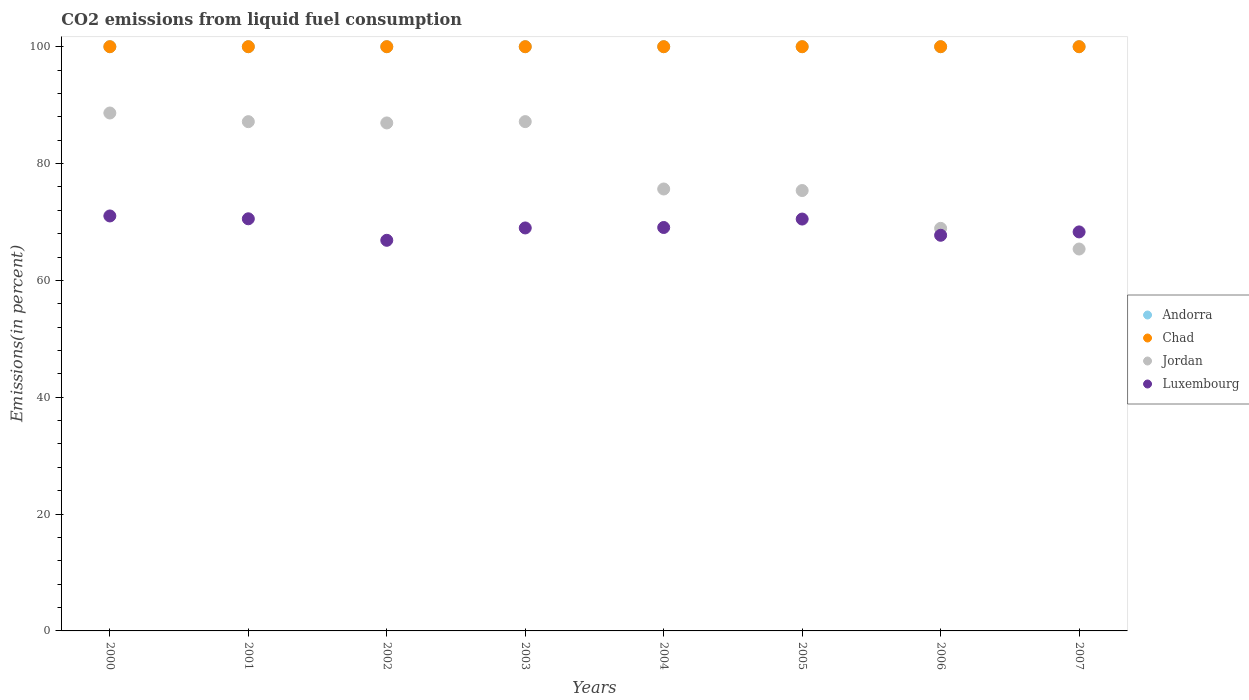Is the number of dotlines equal to the number of legend labels?
Your response must be concise. Yes. What is the total CO2 emitted in Chad in 2000?
Offer a terse response. 100. Across all years, what is the maximum total CO2 emitted in Chad?
Ensure brevity in your answer.  100. Across all years, what is the minimum total CO2 emitted in Luxembourg?
Your answer should be very brief. 66.86. What is the total total CO2 emitted in Luxembourg in the graph?
Provide a short and direct response. 552.98. What is the difference between the total CO2 emitted in Chad in 2002 and that in 2005?
Offer a very short reply. 0. What is the difference between the total CO2 emitted in Andorra in 2003 and the total CO2 emitted in Chad in 2005?
Your answer should be compact. 0. What is the average total CO2 emitted in Luxembourg per year?
Your answer should be very brief. 69.12. In the year 2004, what is the difference between the total CO2 emitted in Andorra and total CO2 emitted in Jordan?
Make the answer very short. 24.36. What is the ratio of the total CO2 emitted in Jordan in 2003 to that in 2005?
Provide a succinct answer. 1.16. Is the difference between the total CO2 emitted in Andorra in 2001 and 2006 greater than the difference between the total CO2 emitted in Jordan in 2001 and 2006?
Your answer should be compact. No. What is the difference between the highest and the second highest total CO2 emitted in Jordan?
Make the answer very short. 1.48. Is it the case that in every year, the sum of the total CO2 emitted in Jordan and total CO2 emitted in Luxembourg  is greater than the total CO2 emitted in Andorra?
Offer a very short reply. Yes. How many years are there in the graph?
Give a very brief answer. 8. Does the graph contain grids?
Your response must be concise. No. How many legend labels are there?
Your answer should be very brief. 4. How are the legend labels stacked?
Make the answer very short. Vertical. What is the title of the graph?
Ensure brevity in your answer.  CO2 emissions from liquid fuel consumption. What is the label or title of the X-axis?
Provide a short and direct response. Years. What is the label or title of the Y-axis?
Provide a short and direct response. Emissions(in percent). What is the Emissions(in percent) of Andorra in 2000?
Provide a succinct answer. 100. What is the Emissions(in percent) in Jordan in 2000?
Keep it short and to the point. 88.65. What is the Emissions(in percent) in Luxembourg in 2000?
Keep it short and to the point. 71.03. What is the Emissions(in percent) in Andorra in 2001?
Offer a terse response. 100. What is the Emissions(in percent) in Chad in 2001?
Offer a very short reply. 100. What is the Emissions(in percent) of Jordan in 2001?
Ensure brevity in your answer.  87.17. What is the Emissions(in percent) in Luxembourg in 2001?
Your answer should be very brief. 70.54. What is the Emissions(in percent) in Jordan in 2002?
Your answer should be very brief. 86.95. What is the Emissions(in percent) of Luxembourg in 2002?
Offer a terse response. 66.86. What is the Emissions(in percent) in Jordan in 2003?
Offer a terse response. 87.17. What is the Emissions(in percent) of Luxembourg in 2003?
Your response must be concise. 68.97. What is the Emissions(in percent) of Jordan in 2004?
Offer a terse response. 75.64. What is the Emissions(in percent) in Luxembourg in 2004?
Make the answer very short. 69.05. What is the Emissions(in percent) in Andorra in 2005?
Offer a very short reply. 100. What is the Emissions(in percent) of Jordan in 2005?
Make the answer very short. 75.38. What is the Emissions(in percent) in Luxembourg in 2005?
Your answer should be compact. 70.5. What is the Emissions(in percent) of Andorra in 2006?
Keep it short and to the point. 100. What is the Emissions(in percent) of Chad in 2006?
Make the answer very short. 100. What is the Emissions(in percent) in Jordan in 2006?
Your answer should be very brief. 68.91. What is the Emissions(in percent) of Luxembourg in 2006?
Ensure brevity in your answer.  67.72. What is the Emissions(in percent) in Chad in 2007?
Offer a very short reply. 100. What is the Emissions(in percent) of Jordan in 2007?
Offer a terse response. 65.37. What is the Emissions(in percent) in Luxembourg in 2007?
Give a very brief answer. 68.3. Across all years, what is the maximum Emissions(in percent) of Andorra?
Your response must be concise. 100. Across all years, what is the maximum Emissions(in percent) in Chad?
Your response must be concise. 100. Across all years, what is the maximum Emissions(in percent) of Jordan?
Your answer should be very brief. 88.65. Across all years, what is the maximum Emissions(in percent) in Luxembourg?
Provide a short and direct response. 71.03. Across all years, what is the minimum Emissions(in percent) in Andorra?
Offer a very short reply. 100. Across all years, what is the minimum Emissions(in percent) in Chad?
Your response must be concise. 100. Across all years, what is the minimum Emissions(in percent) of Jordan?
Provide a succinct answer. 65.37. Across all years, what is the minimum Emissions(in percent) in Luxembourg?
Offer a terse response. 66.86. What is the total Emissions(in percent) in Andorra in the graph?
Offer a terse response. 800. What is the total Emissions(in percent) of Chad in the graph?
Offer a very short reply. 800. What is the total Emissions(in percent) in Jordan in the graph?
Your response must be concise. 635.24. What is the total Emissions(in percent) in Luxembourg in the graph?
Offer a very short reply. 552.98. What is the difference between the Emissions(in percent) in Chad in 2000 and that in 2001?
Make the answer very short. 0. What is the difference between the Emissions(in percent) in Jordan in 2000 and that in 2001?
Provide a succinct answer. 1.48. What is the difference between the Emissions(in percent) of Luxembourg in 2000 and that in 2001?
Your answer should be very brief. 0.49. What is the difference between the Emissions(in percent) of Jordan in 2000 and that in 2002?
Give a very brief answer. 1.7. What is the difference between the Emissions(in percent) of Luxembourg in 2000 and that in 2002?
Keep it short and to the point. 4.17. What is the difference between the Emissions(in percent) in Andorra in 2000 and that in 2003?
Your answer should be very brief. 0. What is the difference between the Emissions(in percent) of Chad in 2000 and that in 2003?
Ensure brevity in your answer.  0. What is the difference between the Emissions(in percent) in Jordan in 2000 and that in 2003?
Provide a short and direct response. 1.48. What is the difference between the Emissions(in percent) in Luxembourg in 2000 and that in 2003?
Your answer should be very brief. 2.05. What is the difference between the Emissions(in percent) of Andorra in 2000 and that in 2004?
Offer a very short reply. 0. What is the difference between the Emissions(in percent) in Jordan in 2000 and that in 2004?
Your answer should be compact. 13.01. What is the difference between the Emissions(in percent) of Luxembourg in 2000 and that in 2004?
Make the answer very short. 1.98. What is the difference between the Emissions(in percent) in Andorra in 2000 and that in 2005?
Your answer should be compact. 0. What is the difference between the Emissions(in percent) of Chad in 2000 and that in 2005?
Offer a very short reply. 0. What is the difference between the Emissions(in percent) in Jordan in 2000 and that in 2005?
Your response must be concise. 13.27. What is the difference between the Emissions(in percent) of Luxembourg in 2000 and that in 2005?
Keep it short and to the point. 0.53. What is the difference between the Emissions(in percent) in Chad in 2000 and that in 2006?
Give a very brief answer. 0. What is the difference between the Emissions(in percent) in Jordan in 2000 and that in 2006?
Provide a short and direct response. 19.74. What is the difference between the Emissions(in percent) of Luxembourg in 2000 and that in 2006?
Your response must be concise. 3.31. What is the difference between the Emissions(in percent) of Jordan in 2000 and that in 2007?
Your answer should be compact. 23.28. What is the difference between the Emissions(in percent) of Luxembourg in 2000 and that in 2007?
Keep it short and to the point. 2.73. What is the difference between the Emissions(in percent) in Andorra in 2001 and that in 2002?
Your response must be concise. 0. What is the difference between the Emissions(in percent) in Jordan in 2001 and that in 2002?
Ensure brevity in your answer.  0.22. What is the difference between the Emissions(in percent) of Luxembourg in 2001 and that in 2002?
Ensure brevity in your answer.  3.68. What is the difference between the Emissions(in percent) of Andorra in 2001 and that in 2003?
Make the answer very short. 0. What is the difference between the Emissions(in percent) of Jordan in 2001 and that in 2003?
Offer a terse response. -0.01. What is the difference between the Emissions(in percent) of Luxembourg in 2001 and that in 2003?
Your response must be concise. 1.57. What is the difference between the Emissions(in percent) in Jordan in 2001 and that in 2004?
Make the answer very short. 11.52. What is the difference between the Emissions(in percent) in Luxembourg in 2001 and that in 2004?
Your answer should be very brief. 1.49. What is the difference between the Emissions(in percent) in Jordan in 2001 and that in 2005?
Provide a short and direct response. 11.79. What is the difference between the Emissions(in percent) in Luxembourg in 2001 and that in 2005?
Offer a very short reply. 0.04. What is the difference between the Emissions(in percent) of Jordan in 2001 and that in 2006?
Your answer should be compact. 18.26. What is the difference between the Emissions(in percent) of Luxembourg in 2001 and that in 2006?
Provide a succinct answer. 2.82. What is the difference between the Emissions(in percent) of Andorra in 2001 and that in 2007?
Your answer should be very brief. 0. What is the difference between the Emissions(in percent) in Chad in 2001 and that in 2007?
Offer a terse response. 0. What is the difference between the Emissions(in percent) of Jordan in 2001 and that in 2007?
Provide a succinct answer. 21.8. What is the difference between the Emissions(in percent) in Luxembourg in 2001 and that in 2007?
Provide a succinct answer. 2.24. What is the difference between the Emissions(in percent) in Jordan in 2002 and that in 2003?
Offer a terse response. -0.23. What is the difference between the Emissions(in percent) in Luxembourg in 2002 and that in 2003?
Your answer should be compact. -2.11. What is the difference between the Emissions(in percent) of Andorra in 2002 and that in 2004?
Offer a terse response. 0. What is the difference between the Emissions(in percent) of Chad in 2002 and that in 2004?
Keep it short and to the point. 0. What is the difference between the Emissions(in percent) in Jordan in 2002 and that in 2004?
Give a very brief answer. 11.31. What is the difference between the Emissions(in percent) of Luxembourg in 2002 and that in 2004?
Your answer should be compact. -2.19. What is the difference between the Emissions(in percent) of Jordan in 2002 and that in 2005?
Offer a terse response. 11.57. What is the difference between the Emissions(in percent) in Luxembourg in 2002 and that in 2005?
Offer a very short reply. -3.64. What is the difference between the Emissions(in percent) in Chad in 2002 and that in 2006?
Provide a succinct answer. 0. What is the difference between the Emissions(in percent) of Jordan in 2002 and that in 2006?
Provide a succinct answer. 18.04. What is the difference between the Emissions(in percent) in Luxembourg in 2002 and that in 2006?
Provide a succinct answer. -0.86. What is the difference between the Emissions(in percent) of Chad in 2002 and that in 2007?
Keep it short and to the point. 0. What is the difference between the Emissions(in percent) of Jordan in 2002 and that in 2007?
Ensure brevity in your answer.  21.58. What is the difference between the Emissions(in percent) in Luxembourg in 2002 and that in 2007?
Keep it short and to the point. -1.44. What is the difference between the Emissions(in percent) of Andorra in 2003 and that in 2004?
Make the answer very short. 0. What is the difference between the Emissions(in percent) in Chad in 2003 and that in 2004?
Provide a succinct answer. 0. What is the difference between the Emissions(in percent) of Jordan in 2003 and that in 2004?
Your response must be concise. 11.53. What is the difference between the Emissions(in percent) of Luxembourg in 2003 and that in 2004?
Your answer should be very brief. -0.08. What is the difference between the Emissions(in percent) in Andorra in 2003 and that in 2005?
Provide a short and direct response. 0. What is the difference between the Emissions(in percent) of Jordan in 2003 and that in 2005?
Keep it short and to the point. 11.8. What is the difference between the Emissions(in percent) of Luxembourg in 2003 and that in 2005?
Provide a short and direct response. -1.52. What is the difference between the Emissions(in percent) in Andorra in 2003 and that in 2006?
Your response must be concise. 0. What is the difference between the Emissions(in percent) of Chad in 2003 and that in 2006?
Ensure brevity in your answer.  0. What is the difference between the Emissions(in percent) of Jordan in 2003 and that in 2006?
Provide a succinct answer. 18.27. What is the difference between the Emissions(in percent) of Luxembourg in 2003 and that in 2006?
Provide a succinct answer. 1.25. What is the difference between the Emissions(in percent) of Chad in 2003 and that in 2007?
Your answer should be very brief. 0. What is the difference between the Emissions(in percent) of Jordan in 2003 and that in 2007?
Keep it short and to the point. 21.81. What is the difference between the Emissions(in percent) in Luxembourg in 2003 and that in 2007?
Keep it short and to the point. 0.68. What is the difference between the Emissions(in percent) of Jordan in 2004 and that in 2005?
Your answer should be compact. 0.26. What is the difference between the Emissions(in percent) of Luxembourg in 2004 and that in 2005?
Provide a short and direct response. -1.45. What is the difference between the Emissions(in percent) of Andorra in 2004 and that in 2006?
Your response must be concise. 0. What is the difference between the Emissions(in percent) in Chad in 2004 and that in 2006?
Give a very brief answer. 0. What is the difference between the Emissions(in percent) in Jordan in 2004 and that in 2006?
Your answer should be very brief. 6.74. What is the difference between the Emissions(in percent) of Luxembourg in 2004 and that in 2006?
Make the answer very short. 1.33. What is the difference between the Emissions(in percent) of Chad in 2004 and that in 2007?
Your answer should be compact. 0. What is the difference between the Emissions(in percent) in Jordan in 2004 and that in 2007?
Offer a terse response. 10.27. What is the difference between the Emissions(in percent) of Luxembourg in 2004 and that in 2007?
Your answer should be very brief. 0.76. What is the difference between the Emissions(in percent) in Andorra in 2005 and that in 2006?
Your answer should be compact. 0. What is the difference between the Emissions(in percent) in Chad in 2005 and that in 2006?
Your response must be concise. 0. What is the difference between the Emissions(in percent) in Jordan in 2005 and that in 2006?
Your response must be concise. 6.47. What is the difference between the Emissions(in percent) of Luxembourg in 2005 and that in 2006?
Provide a short and direct response. 2.78. What is the difference between the Emissions(in percent) of Jordan in 2005 and that in 2007?
Make the answer very short. 10.01. What is the difference between the Emissions(in percent) in Luxembourg in 2005 and that in 2007?
Provide a short and direct response. 2.2. What is the difference between the Emissions(in percent) in Andorra in 2006 and that in 2007?
Make the answer very short. 0. What is the difference between the Emissions(in percent) of Chad in 2006 and that in 2007?
Provide a succinct answer. 0. What is the difference between the Emissions(in percent) of Jordan in 2006 and that in 2007?
Provide a succinct answer. 3.54. What is the difference between the Emissions(in percent) in Luxembourg in 2006 and that in 2007?
Your answer should be very brief. -0.57. What is the difference between the Emissions(in percent) of Andorra in 2000 and the Emissions(in percent) of Chad in 2001?
Provide a short and direct response. 0. What is the difference between the Emissions(in percent) of Andorra in 2000 and the Emissions(in percent) of Jordan in 2001?
Provide a succinct answer. 12.83. What is the difference between the Emissions(in percent) in Andorra in 2000 and the Emissions(in percent) in Luxembourg in 2001?
Keep it short and to the point. 29.46. What is the difference between the Emissions(in percent) of Chad in 2000 and the Emissions(in percent) of Jordan in 2001?
Give a very brief answer. 12.83. What is the difference between the Emissions(in percent) of Chad in 2000 and the Emissions(in percent) of Luxembourg in 2001?
Offer a terse response. 29.46. What is the difference between the Emissions(in percent) in Jordan in 2000 and the Emissions(in percent) in Luxembourg in 2001?
Make the answer very short. 18.11. What is the difference between the Emissions(in percent) in Andorra in 2000 and the Emissions(in percent) in Chad in 2002?
Your answer should be very brief. 0. What is the difference between the Emissions(in percent) in Andorra in 2000 and the Emissions(in percent) in Jordan in 2002?
Your answer should be compact. 13.05. What is the difference between the Emissions(in percent) in Andorra in 2000 and the Emissions(in percent) in Luxembourg in 2002?
Provide a succinct answer. 33.14. What is the difference between the Emissions(in percent) of Chad in 2000 and the Emissions(in percent) of Jordan in 2002?
Offer a terse response. 13.05. What is the difference between the Emissions(in percent) in Chad in 2000 and the Emissions(in percent) in Luxembourg in 2002?
Your answer should be compact. 33.14. What is the difference between the Emissions(in percent) of Jordan in 2000 and the Emissions(in percent) of Luxembourg in 2002?
Make the answer very short. 21.79. What is the difference between the Emissions(in percent) of Andorra in 2000 and the Emissions(in percent) of Chad in 2003?
Keep it short and to the point. 0. What is the difference between the Emissions(in percent) in Andorra in 2000 and the Emissions(in percent) in Jordan in 2003?
Provide a succinct answer. 12.83. What is the difference between the Emissions(in percent) in Andorra in 2000 and the Emissions(in percent) in Luxembourg in 2003?
Make the answer very short. 31.03. What is the difference between the Emissions(in percent) of Chad in 2000 and the Emissions(in percent) of Jordan in 2003?
Your answer should be very brief. 12.83. What is the difference between the Emissions(in percent) in Chad in 2000 and the Emissions(in percent) in Luxembourg in 2003?
Ensure brevity in your answer.  31.03. What is the difference between the Emissions(in percent) in Jordan in 2000 and the Emissions(in percent) in Luxembourg in 2003?
Your answer should be very brief. 19.68. What is the difference between the Emissions(in percent) in Andorra in 2000 and the Emissions(in percent) in Jordan in 2004?
Provide a succinct answer. 24.36. What is the difference between the Emissions(in percent) of Andorra in 2000 and the Emissions(in percent) of Luxembourg in 2004?
Provide a succinct answer. 30.95. What is the difference between the Emissions(in percent) in Chad in 2000 and the Emissions(in percent) in Jordan in 2004?
Ensure brevity in your answer.  24.36. What is the difference between the Emissions(in percent) in Chad in 2000 and the Emissions(in percent) in Luxembourg in 2004?
Your answer should be very brief. 30.95. What is the difference between the Emissions(in percent) of Jordan in 2000 and the Emissions(in percent) of Luxembourg in 2004?
Your answer should be compact. 19.6. What is the difference between the Emissions(in percent) in Andorra in 2000 and the Emissions(in percent) in Chad in 2005?
Ensure brevity in your answer.  0. What is the difference between the Emissions(in percent) of Andorra in 2000 and the Emissions(in percent) of Jordan in 2005?
Offer a terse response. 24.62. What is the difference between the Emissions(in percent) of Andorra in 2000 and the Emissions(in percent) of Luxembourg in 2005?
Offer a very short reply. 29.5. What is the difference between the Emissions(in percent) in Chad in 2000 and the Emissions(in percent) in Jordan in 2005?
Ensure brevity in your answer.  24.62. What is the difference between the Emissions(in percent) of Chad in 2000 and the Emissions(in percent) of Luxembourg in 2005?
Your response must be concise. 29.5. What is the difference between the Emissions(in percent) in Jordan in 2000 and the Emissions(in percent) in Luxembourg in 2005?
Give a very brief answer. 18.15. What is the difference between the Emissions(in percent) of Andorra in 2000 and the Emissions(in percent) of Chad in 2006?
Give a very brief answer. 0. What is the difference between the Emissions(in percent) in Andorra in 2000 and the Emissions(in percent) in Jordan in 2006?
Give a very brief answer. 31.09. What is the difference between the Emissions(in percent) in Andorra in 2000 and the Emissions(in percent) in Luxembourg in 2006?
Provide a short and direct response. 32.28. What is the difference between the Emissions(in percent) of Chad in 2000 and the Emissions(in percent) of Jordan in 2006?
Provide a succinct answer. 31.09. What is the difference between the Emissions(in percent) in Chad in 2000 and the Emissions(in percent) in Luxembourg in 2006?
Your response must be concise. 32.28. What is the difference between the Emissions(in percent) in Jordan in 2000 and the Emissions(in percent) in Luxembourg in 2006?
Offer a terse response. 20.93. What is the difference between the Emissions(in percent) in Andorra in 2000 and the Emissions(in percent) in Chad in 2007?
Your answer should be very brief. 0. What is the difference between the Emissions(in percent) in Andorra in 2000 and the Emissions(in percent) in Jordan in 2007?
Give a very brief answer. 34.63. What is the difference between the Emissions(in percent) of Andorra in 2000 and the Emissions(in percent) of Luxembourg in 2007?
Provide a short and direct response. 31.7. What is the difference between the Emissions(in percent) of Chad in 2000 and the Emissions(in percent) of Jordan in 2007?
Your response must be concise. 34.63. What is the difference between the Emissions(in percent) of Chad in 2000 and the Emissions(in percent) of Luxembourg in 2007?
Provide a succinct answer. 31.7. What is the difference between the Emissions(in percent) of Jordan in 2000 and the Emissions(in percent) of Luxembourg in 2007?
Provide a short and direct response. 20.35. What is the difference between the Emissions(in percent) in Andorra in 2001 and the Emissions(in percent) in Jordan in 2002?
Your answer should be compact. 13.05. What is the difference between the Emissions(in percent) in Andorra in 2001 and the Emissions(in percent) in Luxembourg in 2002?
Your answer should be very brief. 33.14. What is the difference between the Emissions(in percent) of Chad in 2001 and the Emissions(in percent) of Jordan in 2002?
Ensure brevity in your answer.  13.05. What is the difference between the Emissions(in percent) in Chad in 2001 and the Emissions(in percent) in Luxembourg in 2002?
Offer a terse response. 33.14. What is the difference between the Emissions(in percent) in Jordan in 2001 and the Emissions(in percent) in Luxembourg in 2002?
Provide a succinct answer. 20.31. What is the difference between the Emissions(in percent) of Andorra in 2001 and the Emissions(in percent) of Chad in 2003?
Give a very brief answer. 0. What is the difference between the Emissions(in percent) of Andorra in 2001 and the Emissions(in percent) of Jordan in 2003?
Your answer should be compact. 12.83. What is the difference between the Emissions(in percent) of Andorra in 2001 and the Emissions(in percent) of Luxembourg in 2003?
Provide a succinct answer. 31.03. What is the difference between the Emissions(in percent) of Chad in 2001 and the Emissions(in percent) of Jordan in 2003?
Your response must be concise. 12.83. What is the difference between the Emissions(in percent) of Chad in 2001 and the Emissions(in percent) of Luxembourg in 2003?
Offer a very short reply. 31.03. What is the difference between the Emissions(in percent) of Jordan in 2001 and the Emissions(in percent) of Luxembourg in 2003?
Your answer should be very brief. 18.19. What is the difference between the Emissions(in percent) in Andorra in 2001 and the Emissions(in percent) in Chad in 2004?
Keep it short and to the point. 0. What is the difference between the Emissions(in percent) of Andorra in 2001 and the Emissions(in percent) of Jordan in 2004?
Provide a succinct answer. 24.36. What is the difference between the Emissions(in percent) in Andorra in 2001 and the Emissions(in percent) in Luxembourg in 2004?
Keep it short and to the point. 30.95. What is the difference between the Emissions(in percent) of Chad in 2001 and the Emissions(in percent) of Jordan in 2004?
Make the answer very short. 24.36. What is the difference between the Emissions(in percent) in Chad in 2001 and the Emissions(in percent) in Luxembourg in 2004?
Make the answer very short. 30.95. What is the difference between the Emissions(in percent) of Jordan in 2001 and the Emissions(in percent) of Luxembourg in 2004?
Your answer should be compact. 18.11. What is the difference between the Emissions(in percent) of Andorra in 2001 and the Emissions(in percent) of Chad in 2005?
Your response must be concise. 0. What is the difference between the Emissions(in percent) in Andorra in 2001 and the Emissions(in percent) in Jordan in 2005?
Give a very brief answer. 24.62. What is the difference between the Emissions(in percent) of Andorra in 2001 and the Emissions(in percent) of Luxembourg in 2005?
Provide a succinct answer. 29.5. What is the difference between the Emissions(in percent) of Chad in 2001 and the Emissions(in percent) of Jordan in 2005?
Offer a very short reply. 24.62. What is the difference between the Emissions(in percent) of Chad in 2001 and the Emissions(in percent) of Luxembourg in 2005?
Offer a terse response. 29.5. What is the difference between the Emissions(in percent) in Jordan in 2001 and the Emissions(in percent) in Luxembourg in 2005?
Give a very brief answer. 16.67. What is the difference between the Emissions(in percent) in Andorra in 2001 and the Emissions(in percent) in Chad in 2006?
Make the answer very short. 0. What is the difference between the Emissions(in percent) of Andorra in 2001 and the Emissions(in percent) of Jordan in 2006?
Your answer should be compact. 31.09. What is the difference between the Emissions(in percent) in Andorra in 2001 and the Emissions(in percent) in Luxembourg in 2006?
Give a very brief answer. 32.28. What is the difference between the Emissions(in percent) in Chad in 2001 and the Emissions(in percent) in Jordan in 2006?
Your response must be concise. 31.09. What is the difference between the Emissions(in percent) of Chad in 2001 and the Emissions(in percent) of Luxembourg in 2006?
Make the answer very short. 32.28. What is the difference between the Emissions(in percent) in Jordan in 2001 and the Emissions(in percent) in Luxembourg in 2006?
Provide a short and direct response. 19.45. What is the difference between the Emissions(in percent) of Andorra in 2001 and the Emissions(in percent) of Jordan in 2007?
Your answer should be very brief. 34.63. What is the difference between the Emissions(in percent) in Andorra in 2001 and the Emissions(in percent) in Luxembourg in 2007?
Your answer should be compact. 31.7. What is the difference between the Emissions(in percent) of Chad in 2001 and the Emissions(in percent) of Jordan in 2007?
Your answer should be compact. 34.63. What is the difference between the Emissions(in percent) in Chad in 2001 and the Emissions(in percent) in Luxembourg in 2007?
Provide a short and direct response. 31.7. What is the difference between the Emissions(in percent) in Jordan in 2001 and the Emissions(in percent) in Luxembourg in 2007?
Offer a terse response. 18.87. What is the difference between the Emissions(in percent) in Andorra in 2002 and the Emissions(in percent) in Jordan in 2003?
Provide a short and direct response. 12.83. What is the difference between the Emissions(in percent) of Andorra in 2002 and the Emissions(in percent) of Luxembourg in 2003?
Offer a very short reply. 31.03. What is the difference between the Emissions(in percent) of Chad in 2002 and the Emissions(in percent) of Jordan in 2003?
Offer a very short reply. 12.83. What is the difference between the Emissions(in percent) in Chad in 2002 and the Emissions(in percent) in Luxembourg in 2003?
Ensure brevity in your answer.  31.03. What is the difference between the Emissions(in percent) in Jordan in 2002 and the Emissions(in percent) in Luxembourg in 2003?
Offer a very short reply. 17.97. What is the difference between the Emissions(in percent) in Andorra in 2002 and the Emissions(in percent) in Chad in 2004?
Offer a very short reply. 0. What is the difference between the Emissions(in percent) in Andorra in 2002 and the Emissions(in percent) in Jordan in 2004?
Keep it short and to the point. 24.36. What is the difference between the Emissions(in percent) in Andorra in 2002 and the Emissions(in percent) in Luxembourg in 2004?
Your answer should be very brief. 30.95. What is the difference between the Emissions(in percent) in Chad in 2002 and the Emissions(in percent) in Jordan in 2004?
Offer a very short reply. 24.36. What is the difference between the Emissions(in percent) in Chad in 2002 and the Emissions(in percent) in Luxembourg in 2004?
Your answer should be very brief. 30.95. What is the difference between the Emissions(in percent) in Jordan in 2002 and the Emissions(in percent) in Luxembourg in 2004?
Make the answer very short. 17.9. What is the difference between the Emissions(in percent) of Andorra in 2002 and the Emissions(in percent) of Jordan in 2005?
Make the answer very short. 24.62. What is the difference between the Emissions(in percent) in Andorra in 2002 and the Emissions(in percent) in Luxembourg in 2005?
Ensure brevity in your answer.  29.5. What is the difference between the Emissions(in percent) of Chad in 2002 and the Emissions(in percent) of Jordan in 2005?
Give a very brief answer. 24.62. What is the difference between the Emissions(in percent) of Chad in 2002 and the Emissions(in percent) of Luxembourg in 2005?
Make the answer very short. 29.5. What is the difference between the Emissions(in percent) of Jordan in 2002 and the Emissions(in percent) of Luxembourg in 2005?
Provide a short and direct response. 16.45. What is the difference between the Emissions(in percent) of Andorra in 2002 and the Emissions(in percent) of Jordan in 2006?
Provide a succinct answer. 31.09. What is the difference between the Emissions(in percent) in Andorra in 2002 and the Emissions(in percent) in Luxembourg in 2006?
Ensure brevity in your answer.  32.28. What is the difference between the Emissions(in percent) of Chad in 2002 and the Emissions(in percent) of Jordan in 2006?
Your response must be concise. 31.09. What is the difference between the Emissions(in percent) in Chad in 2002 and the Emissions(in percent) in Luxembourg in 2006?
Your response must be concise. 32.28. What is the difference between the Emissions(in percent) in Jordan in 2002 and the Emissions(in percent) in Luxembourg in 2006?
Your response must be concise. 19.23. What is the difference between the Emissions(in percent) in Andorra in 2002 and the Emissions(in percent) in Jordan in 2007?
Provide a succinct answer. 34.63. What is the difference between the Emissions(in percent) in Andorra in 2002 and the Emissions(in percent) in Luxembourg in 2007?
Give a very brief answer. 31.7. What is the difference between the Emissions(in percent) of Chad in 2002 and the Emissions(in percent) of Jordan in 2007?
Give a very brief answer. 34.63. What is the difference between the Emissions(in percent) of Chad in 2002 and the Emissions(in percent) of Luxembourg in 2007?
Offer a terse response. 31.7. What is the difference between the Emissions(in percent) of Jordan in 2002 and the Emissions(in percent) of Luxembourg in 2007?
Make the answer very short. 18.65. What is the difference between the Emissions(in percent) of Andorra in 2003 and the Emissions(in percent) of Chad in 2004?
Keep it short and to the point. 0. What is the difference between the Emissions(in percent) of Andorra in 2003 and the Emissions(in percent) of Jordan in 2004?
Give a very brief answer. 24.36. What is the difference between the Emissions(in percent) in Andorra in 2003 and the Emissions(in percent) in Luxembourg in 2004?
Keep it short and to the point. 30.95. What is the difference between the Emissions(in percent) of Chad in 2003 and the Emissions(in percent) of Jordan in 2004?
Your answer should be very brief. 24.36. What is the difference between the Emissions(in percent) in Chad in 2003 and the Emissions(in percent) in Luxembourg in 2004?
Provide a short and direct response. 30.95. What is the difference between the Emissions(in percent) of Jordan in 2003 and the Emissions(in percent) of Luxembourg in 2004?
Keep it short and to the point. 18.12. What is the difference between the Emissions(in percent) of Andorra in 2003 and the Emissions(in percent) of Chad in 2005?
Your answer should be compact. 0. What is the difference between the Emissions(in percent) in Andorra in 2003 and the Emissions(in percent) in Jordan in 2005?
Provide a succinct answer. 24.62. What is the difference between the Emissions(in percent) of Andorra in 2003 and the Emissions(in percent) of Luxembourg in 2005?
Provide a short and direct response. 29.5. What is the difference between the Emissions(in percent) in Chad in 2003 and the Emissions(in percent) in Jordan in 2005?
Provide a succinct answer. 24.62. What is the difference between the Emissions(in percent) in Chad in 2003 and the Emissions(in percent) in Luxembourg in 2005?
Offer a very short reply. 29.5. What is the difference between the Emissions(in percent) of Jordan in 2003 and the Emissions(in percent) of Luxembourg in 2005?
Give a very brief answer. 16.68. What is the difference between the Emissions(in percent) of Andorra in 2003 and the Emissions(in percent) of Jordan in 2006?
Your response must be concise. 31.09. What is the difference between the Emissions(in percent) in Andorra in 2003 and the Emissions(in percent) in Luxembourg in 2006?
Your answer should be very brief. 32.28. What is the difference between the Emissions(in percent) of Chad in 2003 and the Emissions(in percent) of Jordan in 2006?
Give a very brief answer. 31.09. What is the difference between the Emissions(in percent) of Chad in 2003 and the Emissions(in percent) of Luxembourg in 2006?
Make the answer very short. 32.28. What is the difference between the Emissions(in percent) of Jordan in 2003 and the Emissions(in percent) of Luxembourg in 2006?
Provide a short and direct response. 19.45. What is the difference between the Emissions(in percent) of Andorra in 2003 and the Emissions(in percent) of Jordan in 2007?
Your answer should be compact. 34.63. What is the difference between the Emissions(in percent) of Andorra in 2003 and the Emissions(in percent) of Luxembourg in 2007?
Offer a very short reply. 31.7. What is the difference between the Emissions(in percent) of Chad in 2003 and the Emissions(in percent) of Jordan in 2007?
Offer a terse response. 34.63. What is the difference between the Emissions(in percent) in Chad in 2003 and the Emissions(in percent) in Luxembourg in 2007?
Give a very brief answer. 31.7. What is the difference between the Emissions(in percent) in Jordan in 2003 and the Emissions(in percent) in Luxembourg in 2007?
Offer a very short reply. 18.88. What is the difference between the Emissions(in percent) in Andorra in 2004 and the Emissions(in percent) in Jordan in 2005?
Make the answer very short. 24.62. What is the difference between the Emissions(in percent) of Andorra in 2004 and the Emissions(in percent) of Luxembourg in 2005?
Keep it short and to the point. 29.5. What is the difference between the Emissions(in percent) in Chad in 2004 and the Emissions(in percent) in Jordan in 2005?
Your answer should be compact. 24.62. What is the difference between the Emissions(in percent) in Chad in 2004 and the Emissions(in percent) in Luxembourg in 2005?
Keep it short and to the point. 29.5. What is the difference between the Emissions(in percent) of Jordan in 2004 and the Emissions(in percent) of Luxembourg in 2005?
Give a very brief answer. 5.14. What is the difference between the Emissions(in percent) of Andorra in 2004 and the Emissions(in percent) of Chad in 2006?
Offer a very short reply. 0. What is the difference between the Emissions(in percent) of Andorra in 2004 and the Emissions(in percent) of Jordan in 2006?
Your answer should be compact. 31.09. What is the difference between the Emissions(in percent) of Andorra in 2004 and the Emissions(in percent) of Luxembourg in 2006?
Your answer should be very brief. 32.28. What is the difference between the Emissions(in percent) in Chad in 2004 and the Emissions(in percent) in Jordan in 2006?
Give a very brief answer. 31.09. What is the difference between the Emissions(in percent) of Chad in 2004 and the Emissions(in percent) of Luxembourg in 2006?
Ensure brevity in your answer.  32.28. What is the difference between the Emissions(in percent) of Jordan in 2004 and the Emissions(in percent) of Luxembourg in 2006?
Provide a succinct answer. 7.92. What is the difference between the Emissions(in percent) of Andorra in 2004 and the Emissions(in percent) of Jordan in 2007?
Give a very brief answer. 34.63. What is the difference between the Emissions(in percent) in Andorra in 2004 and the Emissions(in percent) in Luxembourg in 2007?
Provide a short and direct response. 31.7. What is the difference between the Emissions(in percent) in Chad in 2004 and the Emissions(in percent) in Jordan in 2007?
Keep it short and to the point. 34.63. What is the difference between the Emissions(in percent) in Chad in 2004 and the Emissions(in percent) in Luxembourg in 2007?
Your response must be concise. 31.7. What is the difference between the Emissions(in percent) in Jordan in 2004 and the Emissions(in percent) in Luxembourg in 2007?
Offer a very short reply. 7.35. What is the difference between the Emissions(in percent) in Andorra in 2005 and the Emissions(in percent) in Jordan in 2006?
Ensure brevity in your answer.  31.09. What is the difference between the Emissions(in percent) in Andorra in 2005 and the Emissions(in percent) in Luxembourg in 2006?
Provide a short and direct response. 32.28. What is the difference between the Emissions(in percent) in Chad in 2005 and the Emissions(in percent) in Jordan in 2006?
Your answer should be very brief. 31.09. What is the difference between the Emissions(in percent) of Chad in 2005 and the Emissions(in percent) of Luxembourg in 2006?
Keep it short and to the point. 32.28. What is the difference between the Emissions(in percent) in Jordan in 2005 and the Emissions(in percent) in Luxembourg in 2006?
Make the answer very short. 7.66. What is the difference between the Emissions(in percent) in Andorra in 2005 and the Emissions(in percent) in Jordan in 2007?
Your response must be concise. 34.63. What is the difference between the Emissions(in percent) of Andorra in 2005 and the Emissions(in percent) of Luxembourg in 2007?
Your response must be concise. 31.7. What is the difference between the Emissions(in percent) of Chad in 2005 and the Emissions(in percent) of Jordan in 2007?
Keep it short and to the point. 34.63. What is the difference between the Emissions(in percent) in Chad in 2005 and the Emissions(in percent) in Luxembourg in 2007?
Your answer should be very brief. 31.7. What is the difference between the Emissions(in percent) of Jordan in 2005 and the Emissions(in percent) of Luxembourg in 2007?
Your answer should be very brief. 7.08. What is the difference between the Emissions(in percent) of Andorra in 2006 and the Emissions(in percent) of Jordan in 2007?
Provide a short and direct response. 34.63. What is the difference between the Emissions(in percent) of Andorra in 2006 and the Emissions(in percent) of Luxembourg in 2007?
Give a very brief answer. 31.7. What is the difference between the Emissions(in percent) in Chad in 2006 and the Emissions(in percent) in Jordan in 2007?
Your answer should be compact. 34.63. What is the difference between the Emissions(in percent) of Chad in 2006 and the Emissions(in percent) of Luxembourg in 2007?
Your response must be concise. 31.7. What is the difference between the Emissions(in percent) in Jordan in 2006 and the Emissions(in percent) in Luxembourg in 2007?
Give a very brief answer. 0.61. What is the average Emissions(in percent) of Chad per year?
Provide a succinct answer. 100. What is the average Emissions(in percent) in Jordan per year?
Offer a terse response. 79.4. What is the average Emissions(in percent) of Luxembourg per year?
Offer a very short reply. 69.12. In the year 2000, what is the difference between the Emissions(in percent) of Andorra and Emissions(in percent) of Jordan?
Your response must be concise. 11.35. In the year 2000, what is the difference between the Emissions(in percent) in Andorra and Emissions(in percent) in Luxembourg?
Offer a terse response. 28.97. In the year 2000, what is the difference between the Emissions(in percent) of Chad and Emissions(in percent) of Jordan?
Give a very brief answer. 11.35. In the year 2000, what is the difference between the Emissions(in percent) in Chad and Emissions(in percent) in Luxembourg?
Ensure brevity in your answer.  28.97. In the year 2000, what is the difference between the Emissions(in percent) of Jordan and Emissions(in percent) of Luxembourg?
Keep it short and to the point. 17.62. In the year 2001, what is the difference between the Emissions(in percent) in Andorra and Emissions(in percent) in Jordan?
Your answer should be compact. 12.83. In the year 2001, what is the difference between the Emissions(in percent) in Andorra and Emissions(in percent) in Luxembourg?
Give a very brief answer. 29.46. In the year 2001, what is the difference between the Emissions(in percent) in Chad and Emissions(in percent) in Jordan?
Make the answer very short. 12.83. In the year 2001, what is the difference between the Emissions(in percent) in Chad and Emissions(in percent) in Luxembourg?
Provide a short and direct response. 29.46. In the year 2001, what is the difference between the Emissions(in percent) in Jordan and Emissions(in percent) in Luxembourg?
Your answer should be very brief. 16.63. In the year 2002, what is the difference between the Emissions(in percent) of Andorra and Emissions(in percent) of Chad?
Ensure brevity in your answer.  0. In the year 2002, what is the difference between the Emissions(in percent) of Andorra and Emissions(in percent) of Jordan?
Provide a succinct answer. 13.05. In the year 2002, what is the difference between the Emissions(in percent) in Andorra and Emissions(in percent) in Luxembourg?
Your answer should be compact. 33.14. In the year 2002, what is the difference between the Emissions(in percent) in Chad and Emissions(in percent) in Jordan?
Give a very brief answer. 13.05. In the year 2002, what is the difference between the Emissions(in percent) in Chad and Emissions(in percent) in Luxembourg?
Keep it short and to the point. 33.14. In the year 2002, what is the difference between the Emissions(in percent) of Jordan and Emissions(in percent) of Luxembourg?
Provide a short and direct response. 20.09. In the year 2003, what is the difference between the Emissions(in percent) of Andorra and Emissions(in percent) of Chad?
Keep it short and to the point. 0. In the year 2003, what is the difference between the Emissions(in percent) in Andorra and Emissions(in percent) in Jordan?
Give a very brief answer. 12.83. In the year 2003, what is the difference between the Emissions(in percent) in Andorra and Emissions(in percent) in Luxembourg?
Provide a succinct answer. 31.03. In the year 2003, what is the difference between the Emissions(in percent) of Chad and Emissions(in percent) of Jordan?
Provide a succinct answer. 12.83. In the year 2003, what is the difference between the Emissions(in percent) of Chad and Emissions(in percent) of Luxembourg?
Provide a succinct answer. 31.03. In the year 2003, what is the difference between the Emissions(in percent) of Jordan and Emissions(in percent) of Luxembourg?
Offer a very short reply. 18.2. In the year 2004, what is the difference between the Emissions(in percent) of Andorra and Emissions(in percent) of Chad?
Keep it short and to the point. 0. In the year 2004, what is the difference between the Emissions(in percent) in Andorra and Emissions(in percent) in Jordan?
Provide a succinct answer. 24.36. In the year 2004, what is the difference between the Emissions(in percent) in Andorra and Emissions(in percent) in Luxembourg?
Provide a short and direct response. 30.95. In the year 2004, what is the difference between the Emissions(in percent) in Chad and Emissions(in percent) in Jordan?
Your answer should be compact. 24.36. In the year 2004, what is the difference between the Emissions(in percent) of Chad and Emissions(in percent) of Luxembourg?
Ensure brevity in your answer.  30.95. In the year 2004, what is the difference between the Emissions(in percent) in Jordan and Emissions(in percent) in Luxembourg?
Offer a terse response. 6.59. In the year 2005, what is the difference between the Emissions(in percent) of Andorra and Emissions(in percent) of Jordan?
Offer a very short reply. 24.62. In the year 2005, what is the difference between the Emissions(in percent) of Andorra and Emissions(in percent) of Luxembourg?
Your answer should be very brief. 29.5. In the year 2005, what is the difference between the Emissions(in percent) in Chad and Emissions(in percent) in Jordan?
Give a very brief answer. 24.62. In the year 2005, what is the difference between the Emissions(in percent) in Chad and Emissions(in percent) in Luxembourg?
Offer a very short reply. 29.5. In the year 2005, what is the difference between the Emissions(in percent) of Jordan and Emissions(in percent) of Luxembourg?
Offer a terse response. 4.88. In the year 2006, what is the difference between the Emissions(in percent) in Andorra and Emissions(in percent) in Chad?
Offer a terse response. 0. In the year 2006, what is the difference between the Emissions(in percent) in Andorra and Emissions(in percent) in Jordan?
Offer a very short reply. 31.09. In the year 2006, what is the difference between the Emissions(in percent) of Andorra and Emissions(in percent) of Luxembourg?
Offer a very short reply. 32.28. In the year 2006, what is the difference between the Emissions(in percent) in Chad and Emissions(in percent) in Jordan?
Your answer should be compact. 31.09. In the year 2006, what is the difference between the Emissions(in percent) of Chad and Emissions(in percent) of Luxembourg?
Your answer should be compact. 32.28. In the year 2006, what is the difference between the Emissions(in percent) of Jordan and Emissions(in percent) of Luxembourg?
Your response must be concise. 1.18. In the year 2007, what is the difference between the Emissions(in percent) in Andorra and Emissions(in percent) in Jordan?
Provide a succinct answer. 34.63. In the year 2007, what is the difference between the Emissions(in percent) in Andorra and Emissions(in percent) in Luxembourg?
Ensure brevity in your answer.  31.7. In the year 2007, what is the difference between the Emissions(in percent) of Chad and Emissions(in percent) of Jordan?
Offer a terse response. 34.63. In the year 2007, what is the difference between the Emissions(in percent) in Chad and Emissions(in percent) in Luxembourg?
Give a very brief answer. 31.7. In the year 2007, what is the difference between the Emissions(in percent) in Jordan and Emissions(in percent) in Luxembourg?
Your answer should be compact. -2.93. What is the ratio of the Emissions(in percent) in Chad in 2000 to that in 2001?
Provide a short and direct response. 1. What is the ratio of the Emissions(in percent) in Luxembourg in 2000 to that in 2001?
Offer a very short reply. 1.01. What is the ratio of the Emissions(in percent) of Jordan in 2000 to that in 2002?
Make the answer very short. 1.02. What is the ratio of the Emissions(in percent) of Luxembourg in 2000 to that in 2002?
Give a very brief answer. 1.06. What is the ratio of the Emissions(in percent) of Andorra in 2000 to that in 2003?
Provide a short and direct response. 1. What is the ratio of the Emissions(in percent) of Chad in 2000 to that in 2003?
Your answer should be very brief. 1. What is the ratio of the Emissions(in percent) of Jordan in 2000 to that in 2003?
Your answer should be compact. 1.02. What is the ratio of the Emissions(in percent) of Luxembourg in 2000 to that in 2003?
Your answer should be very brief. 1.03. What is the ratio of the Emissions(in percent) in Andorra in 2000 to that in 2004?
Offer a terse response. 1. What is the ratio of the Emissions(in percent) in Jordan in 2000 to that in 2004?
Your answer should be very brief. 1.17. What is the ratio of the Emissions(in percent) in Luxembourg in 2000 to that in 2004?
Your response must be concise. 1.03. What is the ratio of the Emissions(in percent) in Andorra in 2000 to that in 2005?
Ensure brevity in your answer.  1. What is the ratio of the Emissions(in percent) of Chad in 2000 to that in 2005?
Provide a short and direct response. 1. What is the ratio of the Emissions(in percent) in Jordan in 2000 to that in 2005?
Ensure brevity in your answer.  1.18. What is the ratio of the Emissions(in percent) in Luxembourg in 2000 to that in 2005?
Ensure brevity in your answer.  1.01. What is the ratio of the Emissions(in percent) of Andorra in 2000 to that in 2006?
Provide a short and direct response. 1. What is the ratio of the Emissions(in percent) of Chad in 2000 to that in 2006?
Keep it short and to the point. 1. What is the ratio of the Emissions(in percent) in Jordan in 2000 to that in 2006?
Offer a very short reply. 1.29. What is the ratio of the Emissions(in percent) in Luxembourg in 2000 to that in 2006?
Provide a succinct answer. 1.05. What is the ratio of the Emissions(in percent) of Chad in 2000 to that in 2007?
Offer a terse response. 1. What is the ratio of the Emissions(in percent) in Jordan in 2000 to that in 2007?
Keep it short and to the point. 1.36. What is the ratio of the Emissions(in percent) of Andorra in 2001 to that in 2002?
Offer a terse response. 1. What is the ratio of the Emissions(in percent) of Jordan in 2001 to that in 2002?
Your answer should be compact. 1. What is the ratio of the Emissions(in percent) in Luxembourg in 2001 to that in 2002?
Give a very brief answer. 1.05. What is the ratio of the Emissions(in percent) of Luxembourg in 2001 to that in 2003?
Offer a terse response. 1.02. What is the ratio of the Emissions(in percent) of Chad in 2001 to that in 2004?
Offer a terse response. 1. What is the ratio of the Emissions(in percent) in Jordan in 2001 to that in 2004?
Ensure brevity in your answer.  1.15. What is the ratio of the Emissions(in percent) of Luxembourg in 2001 to that in 2004?
Make the answer very short. 1.02. What is the ratio of the Emissions(in percent) of Andorra in 2001 to that in 2005?
Give a very brief answer. 1. What is the ratio of the Emissions(in percent) of Chad in 2001 to that in 2005?
Keep it short and to the point. 1. What is the ratio of the Emissions(in percent) of Jordan in 2001 to that in 2005?
Your answer should be compact. 1.16. What is the ratio of the Emissions(in percent) in Luxembourg in 2001 to that in 2005?
Ensure brevity in your answer.  1. What is the ratio of the Emissions(in percent) in Andorra in 2001 to that in 2006?
Give a very brief answer. 1. What is the ratio of the Emissions(in percent) of Jordan in 2001 to that in 2006?
Offer a terse response. 1.26. What is the ratio of the Emissions(in percent) in Luxembourg in 2001 to that in 2006?
Make the answer very short. 1.04. What is the ratio of the Emissions(in percent) of Jordan in 2001 to that in 2007?
Offer a terse response. 1.33. What is the ratio of the Emissions(in percent) in Luxembourg in 2001 to that in 2007?
Your answer should be very brief. 1.03. What is the ratio of the Emissions(in percent) in Luxembourg in 2002 to that in 2003?
Ensure brevity in your answer.  0.97. What is the ratio of the Emissions(in percent) of Andorra in 2002 to that in 2004?
Your answer should be compact. 1. What is the ratio of the Emissions(in percent) of Chad in 2002 to that in 2004?
Ensure brevity in your answer.  1. What is the ratio of the Emissions(in percent) in Jordan in 2002 to that in 2004?
Your response must be concise. 1.15. What is the ratio of the Emissions(in percent) of Luxembourg in 2002 to that in 2004?
Provide a short and direct response. 0.97. What is the ratio of the Emissions(in percent) in Jordan in 2002 to that in 2005?
Provide a short and direct response. 1.15. What is the ratio of the Emissions(in percent) in Luxembourg in 2002 to that in 2005?
Ensure brevity in your answer.  0.95. What is the ratio of the Emissions(in percent) of Jordan in 2002 to that in 2006?
Offer a very short reply. 1.26. What is the ratio of the Emissions(in percent) of Luxembourg in 2002 to that in 2006?
Provide a short and direct response. 0.99. What is the ratio of the Emissions(in percent) in Andorra in 2002 to that in 2007?
Keep it short and to the point. 1. What is the ratio of the Emissions(in percent) in Jordan in 2002 to that in 2007?
Make the answer very short. 1.33. What is the ratio of the Emissions(in percent) of Jordan in 2003 to that in 2004?
Offer a very short reply. 1.15. What is the ratio of the Emissions(in percent) in Andorra in 2003 to that in 2005?
Give a very brief answer. 1. What is the ratio of the Emissions(in percent) of Chad in 2003 to that in 2005?
Your response must be concise. 1. What is the ratio of the Emissions(in percent) in Jordan in 2003 to that in 2005?
Offer a very short reply. 1.16. What is the ratio of the Emissions(in percent) of Luxembourg in 2003 to that in 2005?
Provide a short and direct response. 0.98. What is the ratio of the Emissions(in percent) in Andorra in 2003 to that in 2006?
Your response must be concise. 1. What is the ratio of the Emissions(in percent) in Jordan in 2003 to that in 2006?
Provide a succinct answer. 1.27. What is the ratio of the Emissions(in percent) in Luxembourg in 2003 to that in 2006?
Offer a very short reply. 1.02. What is the ratio of the Emissions(in percent) in Andorra in 2003 to that in 2007?
Your response must be concise. 1. What is the ratio of the Emissions(in percent) in Jordan in 2003 to that in 2007?
Offer a very short reply. 1.33. What is the ratio of the Emissions(in percent) of Luxembourg in 2003 to that in 2007?
Ensure brevity in your answer.  1.01. What is the ratio of the Emissions(in percent) of Jordan in 2004 to that in 2005?
Ensure brevity in your answer.  1. What is the ratio of the Emissions(in percent) in Luxembourg in 2004 to that in 2005?
Ensure brevity in your answer.  0.98. What is the ratio of the Emissions(in percent) of Andorra in 2004 to that in 2006?
Provide a succinct answer. 1. What is the ratio of the Emissions(in percent) in Chad in 2004 to that in 2006?
Provide a short and direct response. 1. What is the ratio of the Emissions(in percent) in Jordan in 2004 to that in 2006?
Ensure brevity in your answer.  1.1. What is the ratio of the Emissions(in percent) in Luxembourg in 2004 to that in 2006?
Provide a short and direct response. 1.02. What is the ratio of the Emissions(in percent) of Andorra in 2004 to that in 2007?
Ensure brevity in your answer.  1. What is the ratio of the Emissions(in percent) in Chad in 2004 to that in 2007?
Offer a very short reply. 1. What is the ratio of the Emissions(in percent) of Jordan in 2004 to that in 2007?
Give a very brief answer. 1.16. What is the ratio of the Emissions(in percent) of Luxembourg in 2004 to that in 2007?
Ensure brevity in your answer.  1.01. What is the ratio of the Emissions(in percent) in Andorra in 2005 to that in 2006?
Your answer should be very brief. 1. What is the ratio of the Emissions(in percent) in Jordan in 2005 to that in 2006?
Your answer should be compact. 1.09. What is the ratio of the Emissions(in percent) of Luxembourg in 2005 to that in 2006?
Your answer should be very brief. 1.04. What is the ratio of the Emissions(in percent) of Andorra in 2005 to that in 2007?
Ensure brevity in your answer.  1. What is the ratio of the Emissions(in percent) of Chad in 2005 to that in 2007?
Provide a succinct answer. 1. What is the ratio of the Emissions(in percent) in Jordan in 2005 to that in 2007?
Your answer should be very brief. 1.15. What is the ratio of the Emissions(in percent) of Luxembourg in 2005 to that in 2007?
Keep it short and to the point. 1.03. What is the ratio of the Emissions(in percent) in Jordan in 2006 to that in 2007?
Ensure brevity in your answer.  1.05. What is the ratio of the Emissions(in percent) of Luxembourg in 2006 to that in 2007?
Provide a succinct answer. 0.99. What is the difference between the highest and the second highest Emissions(in percent) in Andorra?
Offer a very short reply. 0. What is the difference between the highest and the second highest Emissions(in percent) in Jordan?
Give a very brief answer. 1.48. What is the difference between the highest and the second highest Emissions(in percent) of Luxembourg?
Your answer should be compact. 0.49. What is the difference between the highest and the lowest Emissions(in percent) in Chad?
Offer a very short reply. 0. What is the difference between the highest and the lowest Emissions(in percent) in Jordan?
Your answer should be compact. 23.28. What is the difference between the highest and the lowest Emissions(in percent) of Luxembourg?
Provide a succinct answer. 4.17. 